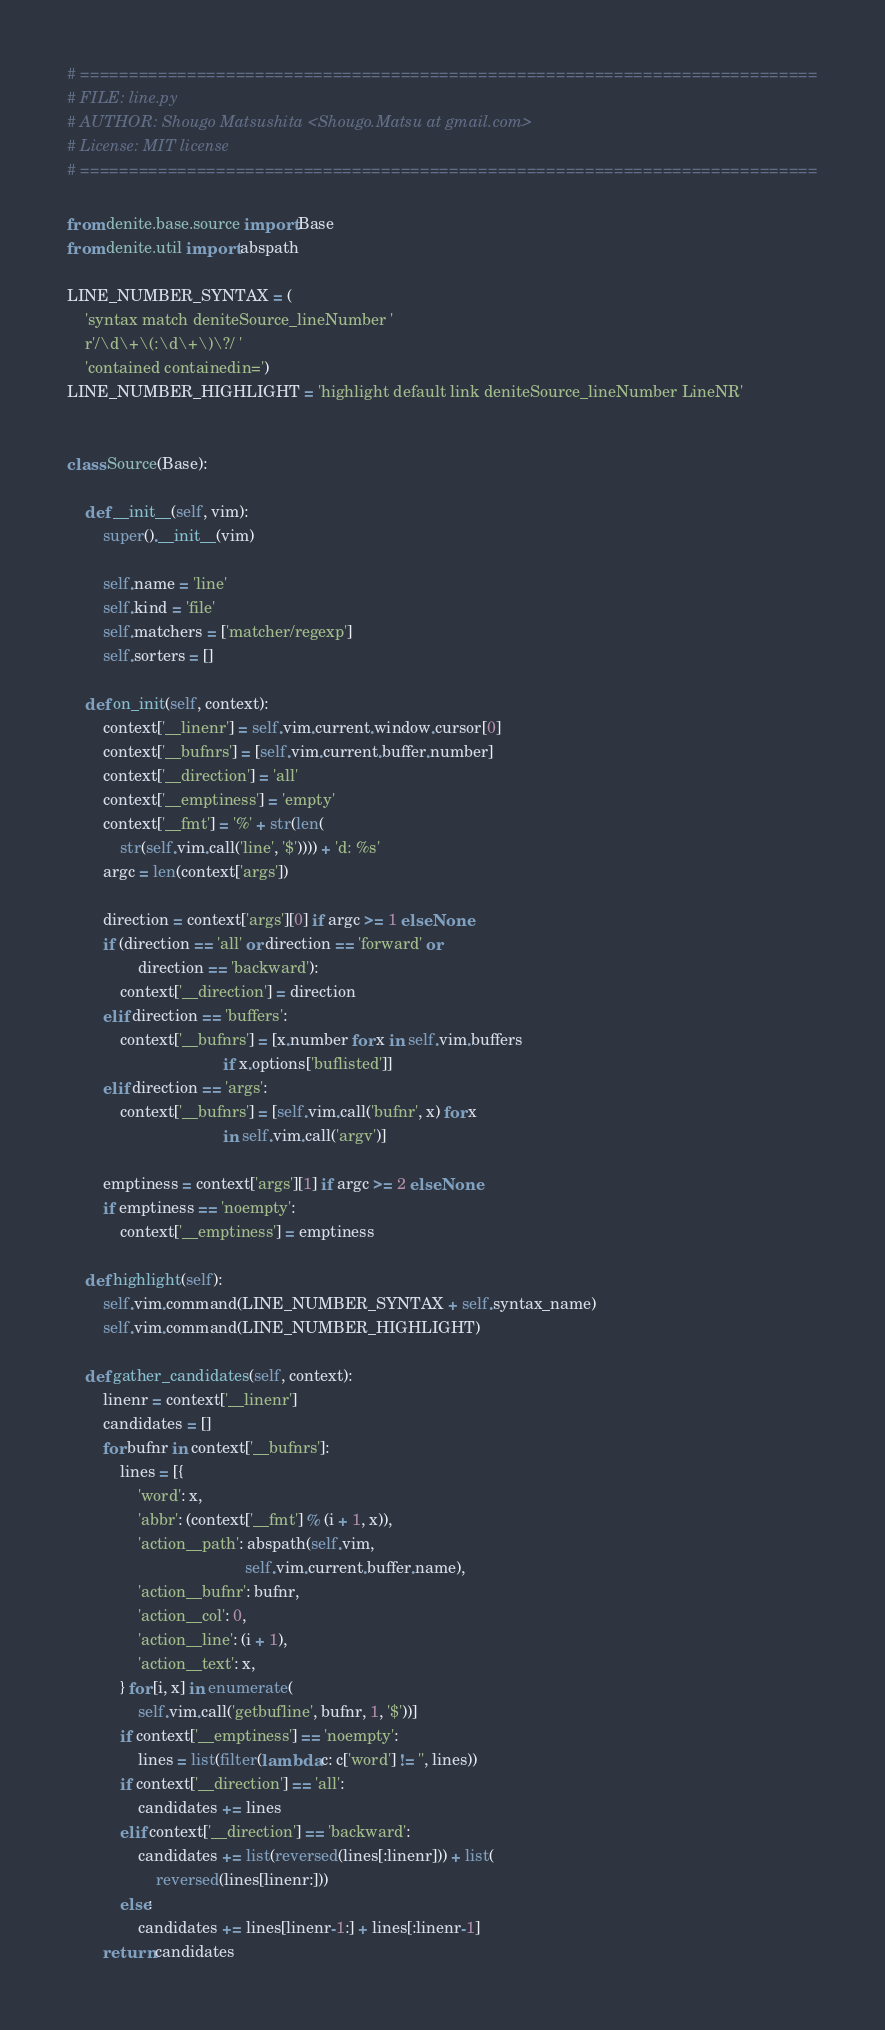Convert code to text. <code><loc_0><loc_0><loc_500><loc_500><_Python_># ============================================================================
# FILE: line.py
# AUTHOR: Shougo Matsushita <Shougo.Matsu at gmail.com>
# License: MIT license
# ============================================================================

from denite.base.source import Base
from denite.util import abspath

LINE_NUMBER_SYNTAX = (
    'syntax match deniteSource_lineNumber '
    r'/\d\+\(:\d\+\)\?/ '
    'contained containedin=')
LINE_NUMBER_HIGHLIGHT = 'highlight default link deniteSource_lineNumber LineNR'


class Source(Base):

    def __init__(self, vim):
        super().__init__(vim)

        self.name = 'line'
        self.kind = 'file'
        self.matchers = ['matcher/regexp']
        self.sorters = []

    def on_init(self, context):
        context['__linenr'] = self.vim.current.window.cursor[0]
        context['__bufnrs'] = [self.vim.current.buffer.number]
        context['__direction'] = 'all'
        context['__emptiness'] = 'empty'
        context['__fmt'] = '%' + str(len(
            str(self.vim.call('line', '$')))) + 'd: %s'
        argc = len(context['args'])

        direction = context['args'][0] if argc >= 1 else None
        if (direction == 'all' or direction == 'forward' or
                direction == 'backward'):
            context['__direction'] = direction
        elif direction == 'buffers':
            context['__bufnrs'] = [x.number for x in self.vim.buffers
                                   if x.options['buflisted']]
        elif direction == 'args':
            context['__bufnrs'] = [self.vim.call('bufnr', x) for x
                                   in self.vim.call('argv')]

        emptiness = context['args'][1] if argc >= 2 else None
        if emptiness == 'noempty':
            context['__emptiness'] = emptiness

    def highlight(self):
        self.vim.command(LINE_NUMBER_SYNTAX + self.syntax_name)
        self.vim.command(LINE_NUMBER_HIGHLIGHT)

    def gather_candidates(self, context):
        linenr = context['__linenr']
        candidates = []
        for bufnr in context['__bufnrs']:
            lines = [{
                'word': x,
                'abbr': (context['__fmt'] % (i + 1, x)),
                'action__path': abspath(self.vim,
                                        self.vim.current.buffer.name),
                'action__bufnr': bufnr,
                'action__col': 0,
                'action__line': (i + 1),
                'action__text': x,
            } for [i, x] in enumerate(
                self.vim.call('getbufline', bufnr, 1, '$'))]
            if context['__emptiness'] == 'noempty':
                lines = list(filter(lambda c: c['word'] != '', lines))
            if context['__direction'] == 'all':
                candidates += lines
            elif context['__direction'] == 'backward':
                candidates += list(reversed(lines[:linenr])) + list(
                    reversed(lines[linenr:]))
            else:
                candidates += lines[linenr-1:] + lines[:linenr-1]
        return candidates
</code> 